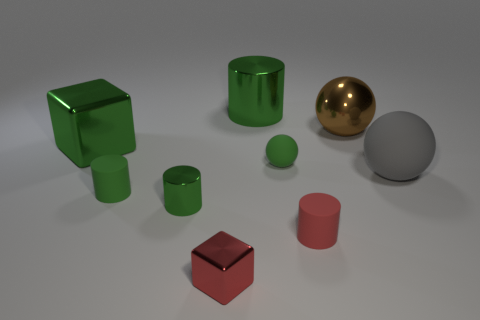Are there any blocks in front of the tiny red rubber thing?
Offer a very short reply. Yes. What material is the brown object?
Offer a very short reply. Metal. There is a metal cylinder that is in front of the green block; is its color the same as the big matte ball?
Your answer should be compact. No. There is a tiny thing that is the same shape as the big rubber thing; what is its color?
Provide a succinct answer. Green. What material is the green cube that is on the left side of the brown metal ball?
Provide a succinct answer. Metal. The large shiny ball is what color?
Provide a succinct answer. Brown. There is a red thing left of the red rubber object; does it have the same size as the green rubber sphere?
Ensure brevity in your answer.  Yes. There is a big thing in front of the large thing that is left of the big green object behind the big brown shiny ball; what is its material?
Make the answer very short. Rubber. There is a shiny cylinder behind the big brown metal ball; does it have the same color as the tiny matte object that is to the left of the red cube?
Give a very brief answer. Yes. What material is the small cylinder on the right side of the ball that is on the left side of the small red cylinder?
Make the answer very short. Rubber. 